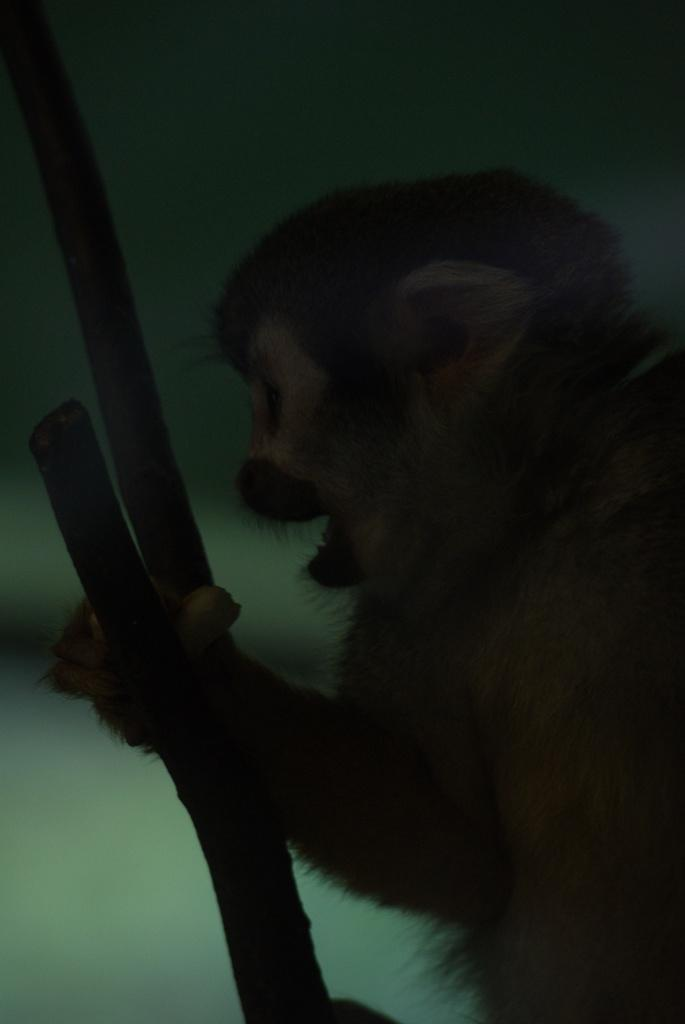What type of animal is present in the image? There is a monkey in the image. What is the purpose of the laborer in the image? There is no laborer present in the image; it features a monkey. How can we describe the noise level of the monkey in the image? The noise level of the monkey cannot be determined from the image alone, as it does not provide any information about the monkey's behavior or sounds. 